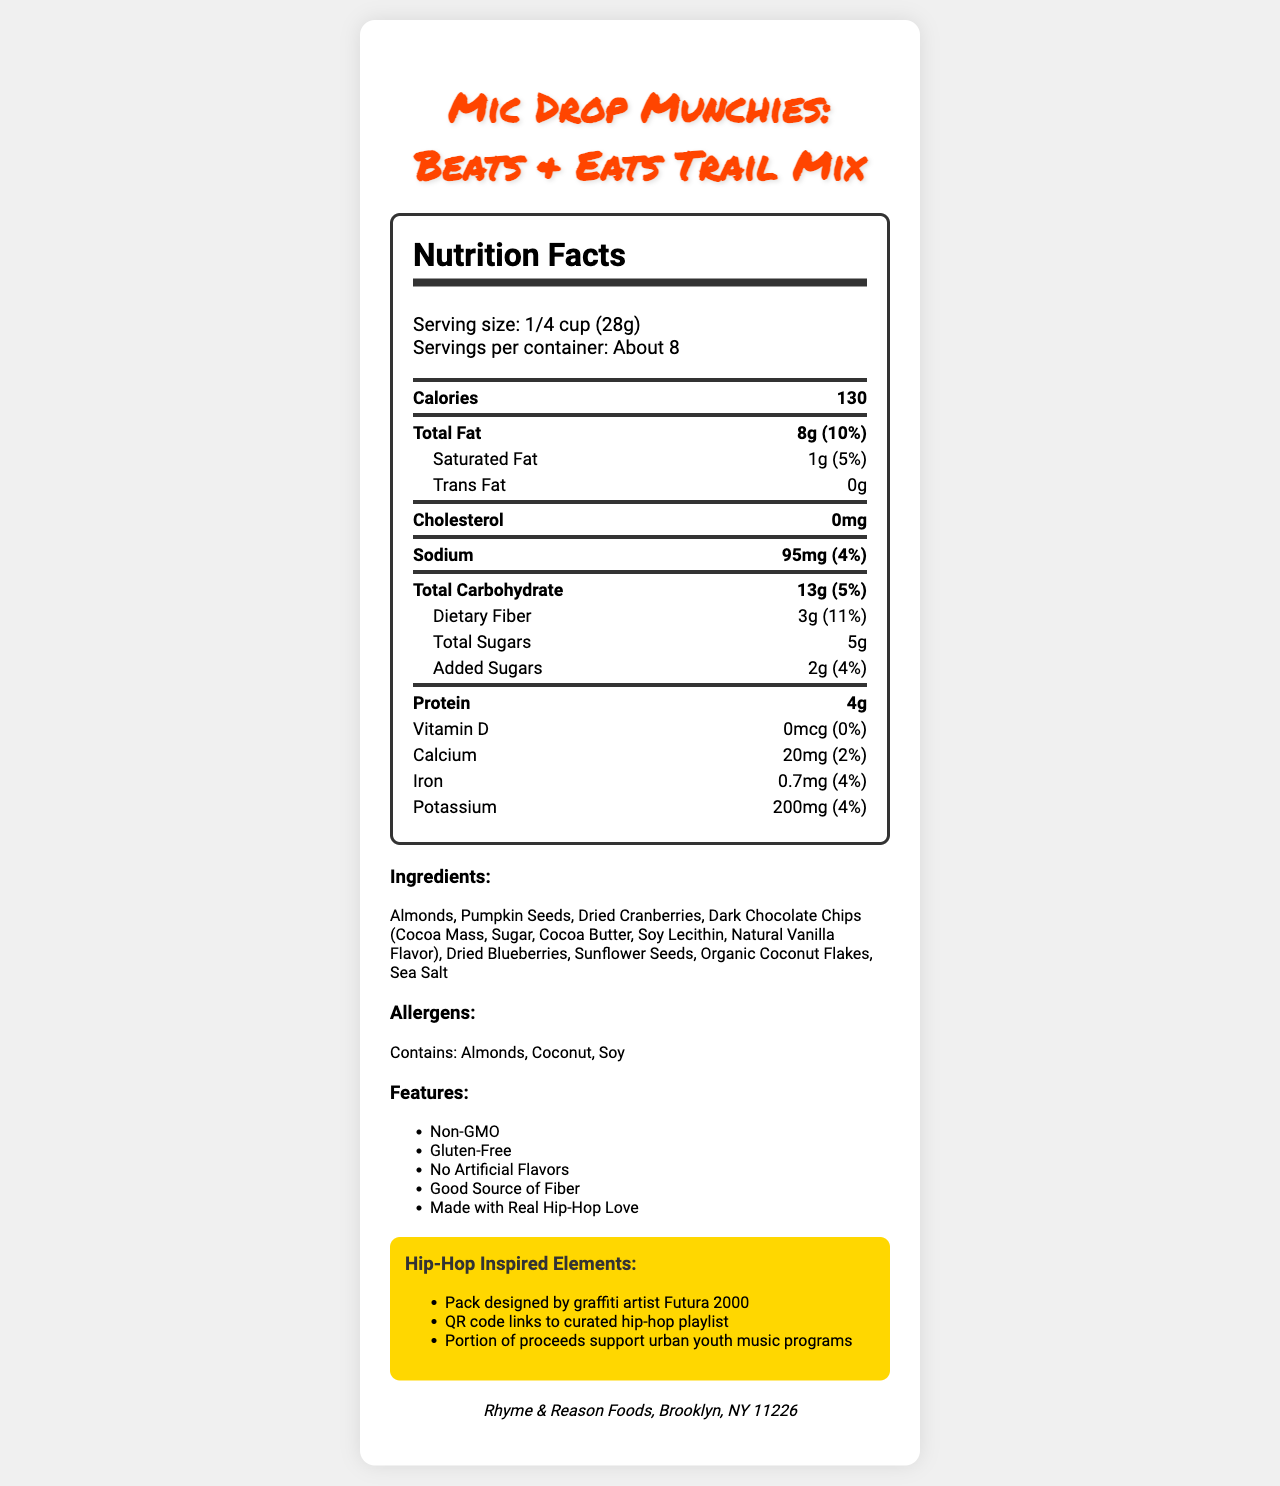what is the serving size for Mic Drop Munchies: Beats & Eats Trail Mix? The serving size is explicitly stated as 1/4 cup (28g) in the nutrition label.
Answer: 1/4 cup (28g) How many servings are there per container? The label states that there are about 8 servings per container.
Answer: About 8 How many calories are there per serving? The nutrition facts section lists 130 calories per serving.
Answer: 130 What is the total fat content per serving? The total fat per serving is noted as 8g on the label.
Answer: 8g List the allergens present in the product. The allergens section mentions that the product contains Almonds, Coconut, and Soy.
Answer: Almonds, Coconut, Soy What percentage of daily value is the dietary fiber per serving? The daily value percentage for dietary fiber per serving is listed as 11%.
Answer: 11% What is the amount of added sugars in the product? The label indicates that there are 2g of added sugars per serving.
Answer: 2g Who is the pack designer for the product? Under the hip-hop-inspired elements, it is mentioned that the pack was designed by graffiti artist Futura 2000.
Answer: Futura 2000 What is the sodium content per serving? The sodium content is listed as 95mg per serving.
Answer: 95mg Which of the following are features of this product? A. Artificial Flavors B. Non-GMO C. Contains Gluten D. Good Source of Fiber The label notes "Non-GMO" and "Good Source of Fiber" as part of the product features.
Answer: B. Non-GMO and D. Good Source of Fiber Who manufactures the Mic Drop Munchies: Beats & Eats Trail Mix? A. Brooklyn Foods B. Hip-Hop Snacks Inc. C. Rhyme & Reason Foods The manufacturer is listed as Rhyme & Reason Foods, Brooklyn, NY 11226.
Answer: C. Rhyme & Reason Foods Is there any trans fat in this product? The label clearly states that there are 0g of trans fat in the product.
Answer: No Provide a brief summary of the main elements of this document. The document covers the nutrition facts, ingredients, allergens, marketing claims, hip-hop-inspired elements, and manufacturer details for the product Mic Drop Munchies: Beats & Eats Trail Mix.
Answer: The Mic Drop Munchies: Beats & Eats Trail Mix is a hip-hop-inspired healthy snack with a serving size of 1/4 cup (28g), yielding about 8 servings per container and 130 calories per serving. It's non-GMO, gluten-free, and has no artificial flavors. It contains allergens like almonds, coconut, and soy, and features hip-hop-inspired elements such as a pack design by Futura 2000 and a QR code linking to a curated hip-hop playlist. What are the health benefits of the product? The document does not provide specific information on health benefits beyond the nutritional facts and marketing claims like being a good source of fiber and non-GMO.
Answer: Not enough information How much protein does one serving provide? According to the nutrition facts, one serving provides 4g of protein.
Answer: 4g 